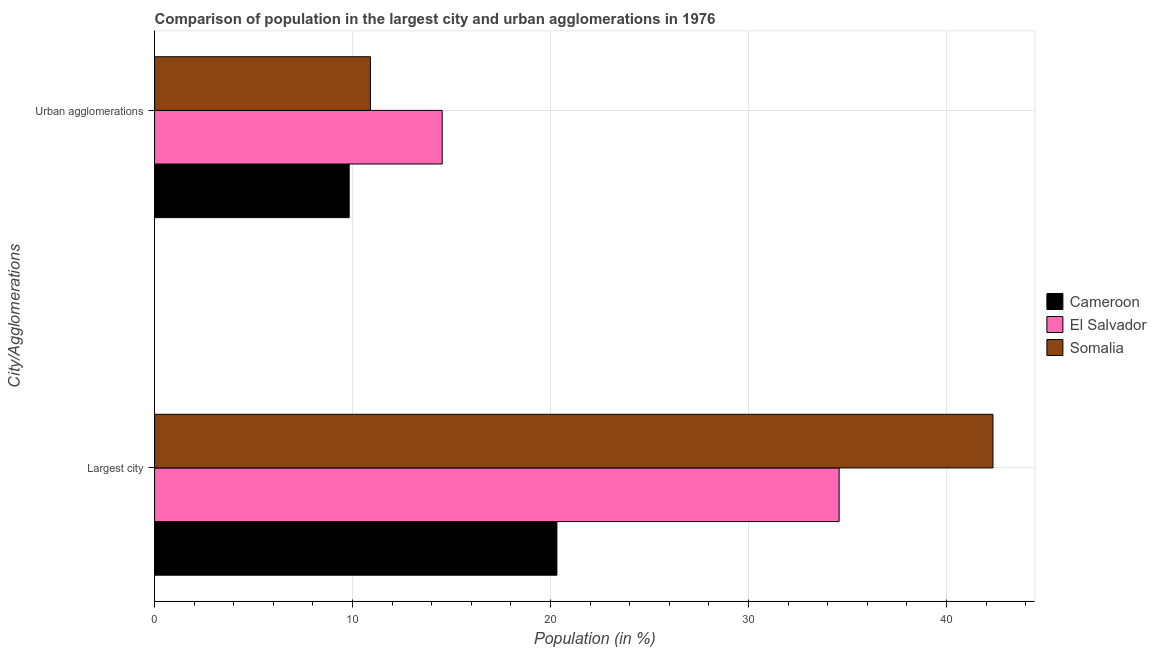How many groups of bars are there?
Your answer should be very brief. 2. Are the number of bars per tick equal to the number of legend labels?
Your response must be concise. Yes. How many bars are there on the 1st tick from the top?
Keep it short and to the point. 3. How many bars are there on the 2nd tick from the bottom?
Offer a very short reply. 3. What is the label of the 1st group of bars from the top?
Ensure brevity in your answer.  Urban agglomerations. What is the population in urban agglomerations in Cameroon?
Keep it short and to the point. 9.83. Across all countries, what is the maximum population in the largest city?
Your answer should be compact. 42.35. Across all countries, what is the minimum population in urban agglomerations?
Offer a terse response. 9.83. In which country was the population in urban agglomerations maximum?
Make the answer very short. El Salvador. In which country was the population in the largest city minimum?
Keep it short and to the point. Cameroon. What is the total population in the largest city in the graph?
Give a very brief answer. 97.24. What is the difference between the population in urban agglomerations in Cameroon and that in Somalia?
Offer a very short reply. -1.07. What is the difference between the population in urban agglomerations in Cameroon and the population in the largest city in Somalia?
Provide a short and direct response. -32.52. What is the average population in the largest city per country?
Provide a succinct answer. 32.41. What is the difference between the population in the largest city and population in urban agglomerations in Cameroon?
Ensure brevity in your answer.  10.49. In how many countries, is the population in the largest city greater than 4 %?
Your answer should be compact. 3. What is the ratio of the population in urban agglomerations in Somalia to that in El Salvador?
Keep it short and to the point. 0.75. Is the population in urban agglomerations in Cameroon less than that in Somalia?
Your answer should be very brief. Yes. What does the 1st bar from the top in Largest city represents?
Ensure brevity in your answer.  Somalia. What does the 1st bar from the bottom in Largest city represents?
Ensure brevity in your answer.  Cameroon. How many bars are there?
Offer a very short reply. 6. Are all the bars in the graph horizontal?
Ensure brevity in your answer.  Yes. What is the difference between two consecutive major ticks on the X-axis?
Provide a short and direct response. 10. Does the graph contain grids?
Offer a very short reply. Yes. How many legend labels are there?
Ensure brevity in your answer.  3. What is the title of the graph?
Give a very brief answer. Comparison of population in the largest city and urban agglomerations in 1976. What is the label or title of the Y-axis?
Make the answer very short. City/Agglomerations. What is the Population (in %) of Cameroon in Largest city?
Your response must be concise. 20.32. What is the Population (in %) in El Salvador in Largest city?
Make the answer very short. 34.58. What is the Population (in %) in Somalia in Largest city?
Your response must be concise. 42.35. What is the Population (in %) in Cameroon in Urban agglomerations?
Ensure brevity in your answer.  9.83. What is the Population (in %) of El Salvador in Urban agglomerations?
Provide a succinct answer. 14.53. What is the Population (in %) in Somalia in Urban agglomerations?
Your response must be concise. 10.9. Across all City/Agglomerations, what is the maximum Population (in %) in Cameroon?
Offer a terse response. 20.32. Across all City/Agglomerations, what is the maximum Population (in %) in El Salvador?
Your answer should be very brief. 34.58. Across all City/Agglomerations, what is the maximum Population (in %) in Somalia?
Offer a very short reply. 42.35. Across all City/Agglomerations, what is the minimum Population (in %) in Cameroon?
Your answer should be compact. 9.83. Across all City/Agglomerations, what is the minimum Population (in %) in El Salvador?
Offer a very short reply. 14.53. Across all City/Agglomerations, what is the minimum Population (in %) of Somalia?
Your answer should be very brief. 10.9. What is the total Population (in %) of Cameroon in the graph?
Provide a succinct answer. 30.15. What is the total Population (in %) in El Salvador in the graph?
Your response must be concise. 49.1. What is the total Population (in %) of Somalia in the graph?
Provide a short and direct response. 53.25. What is the difference between the Population (in %) of Cameroon in Largest city and that in Urban agglomerations?
Provide a short and direct response. 10.49. What is the difference between the Population (in %) of El Salvador in Largest city and that in Urban agglomerations?
Your answer should be very brief. 20.05. What is the difference between the Population (in %) of Somalia in Largest city and that in Urban agglomerations?
Your answer should be compact. 31.44. What is the difference between the Population (in %) in Cameroon in Largest city and the Population (in %) in El Salvador in Urban agglomerations?
Your answer should be compact. 5.79. What is the difference between the Population (in %) in Cameroon in Largest city and the Population (in %) in Somalia in Urban agglomerations?
Your answer should be very brief. 9.42. What is the difference between the Population (in %) of El Salvador in Largest city and the Population (in %) of Somalia in Urban agglomerations?
Your answer should be compact. 23.67. What is the average Population (in %) of Cameroon per City/Agglomerations?
Offer a terse response. 15.07. What is the average Population (in %) in El Salvador per City/Agglomerations?
Your response must be concise. 24.55. What is the average Population (in %) in Somalia per City/Agglomerations?
Offer a terse response. 26.62. What is the difference between the Population (in %) in Cameroon and Population (in %) in El Salvador in Largest city?
Your answer should be very brief. -14.25. What is the difference between the Population (in %) in Cameroon and Population (in %) in Somalia in Largest city?
Give a very brief answer. -22.02. What is the difference between the Population (in %) of El Salvador and Population (in %) of Somalia in Largest city?
Your response must be concise. -7.77. What is the difference between the Population (in %) in Cameroon and Population (in %) in El Salvador in Urban agglomerations?
Provide a short and direct response. -4.7. What is the difference between the Population (in %) of Cameroon and Population (in %) of Somalia in Urban agglomerations?
Provide a succinct answer. -1.07. What is the difference between the Population (in %) in El Salvador and Population (in %) in Somalia in Urban agglomerations?
Your answer should be very brief. 3.62. What is the ratio of the Population (in %) of Cameroon in Largest city to that in Urban agglomerations?
Make the answer very short. 2.07. What is the ratio of the Population (in %) of El Salvador in Largest city to that in Urban agglomerations?
Your answer should be very brief. 2.38. What is the ratio of the Population (in %) in Somalia in Largest city to that in Urban agglomerations?
Provide a short and direct response. 3.88. What is the difference between the highest and the second highest Population (in %) of Cameroon?
Provide a succinct answer. 10.49. What is the difference between the highest and the second highest Population (in %) of El Salvador?
Offer a very short reply. 20.05. What is the difference between the highest and the second highest Population (in %) of Somalia?
Offer a very short reply. 31.44. What is the difference between the highest and the lowest Population (in %) in Cameroon?
Your answer should be very brief. 10.49. What is the difference between the highest and the lowest Population (in %) in El Salvador?
Your response must be concise. 20.05. What is the difference between the highest and the lowest Population (in %) of Somalia?
Offer a very short reply. 31.44. 